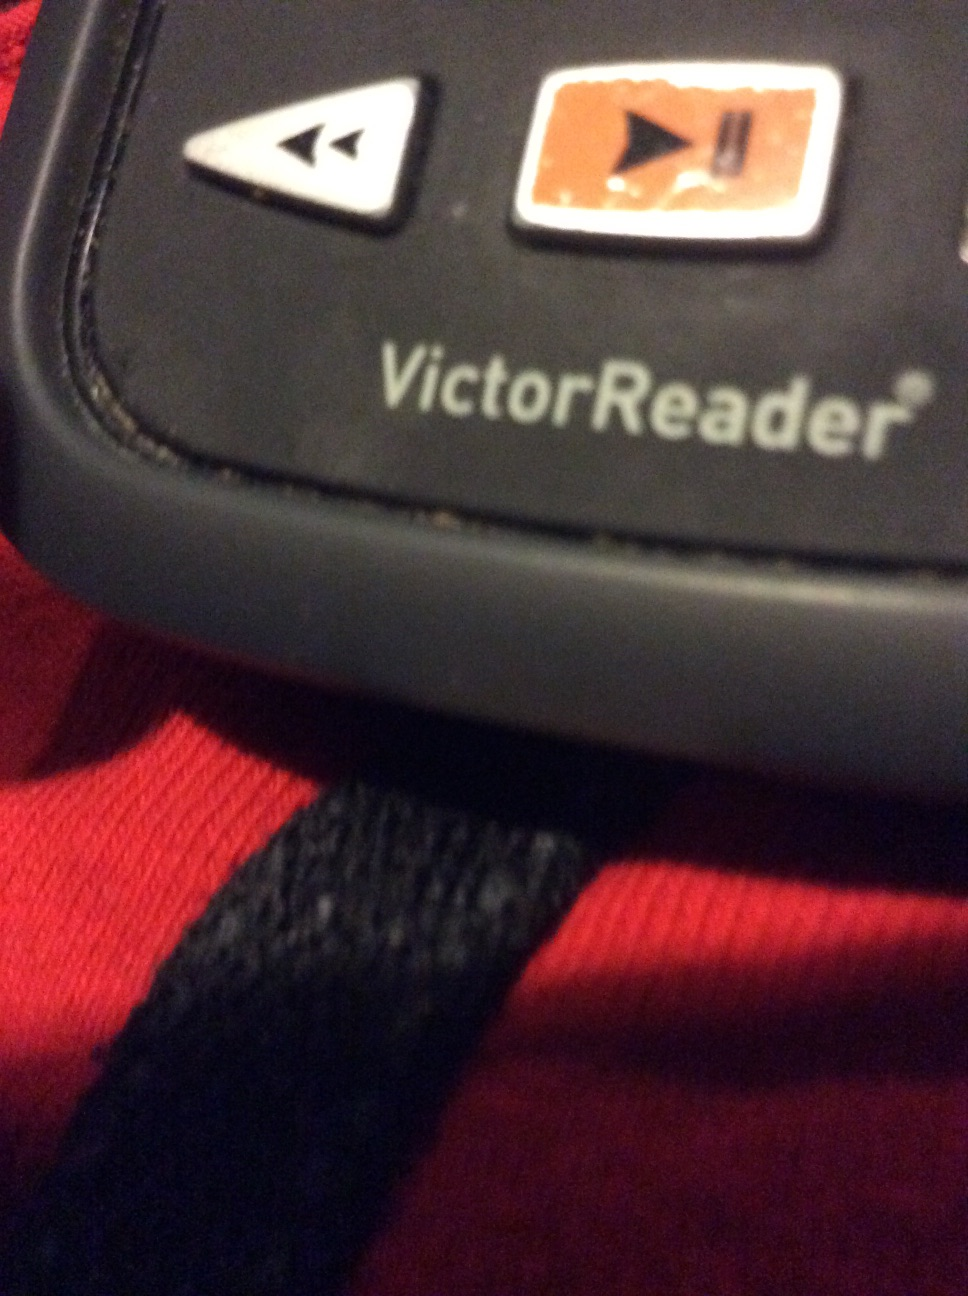What potential improvements or features could be added to the VictorReader in the future? Future improvements for the VictorReader could include integrated internet connectivity for accessing online libraries and resources, customizable voice options, enhanced touch feedback for better navigation, and built-in artificial intelligence to assist with complex navigation commands or answer questions about the content being read. 